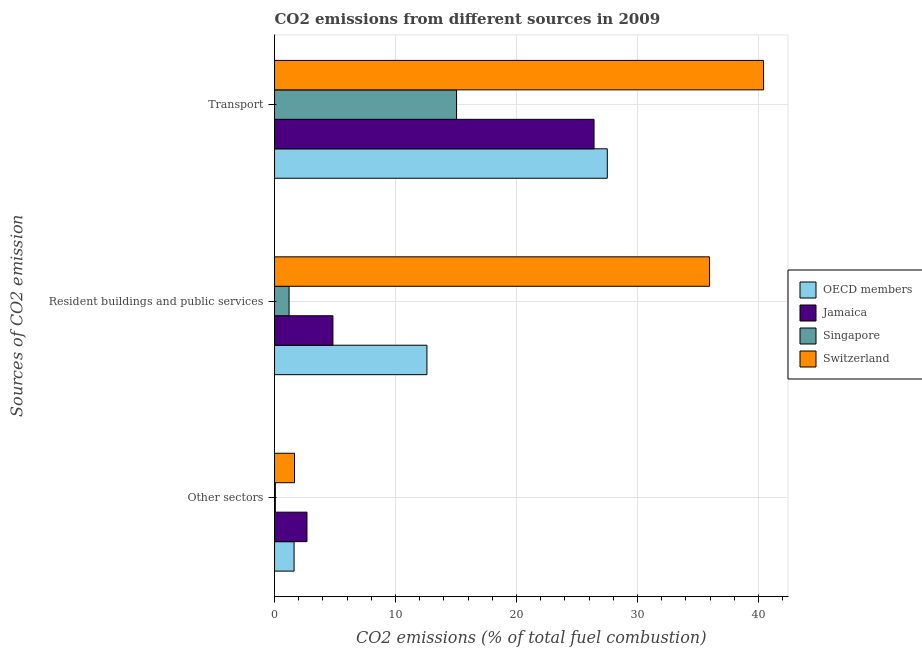How many groups of bars are there?
Give a very brief answer. 3. Are the number of bars on each tick of the Y-axis equal?
Make the answer very short. Yes. How many bars are there on the 1st tick from the top?
Offer a terse response. 4. What is the label of the 2nd group of bars from the top?
Your response must be concise. Resident buildings and public services. What is the percentage of co2 emissions from transport in Jamaica?
Provide a short and direct response. 26.41. Across all countries, what is the maximum percentage of co2 emissions from transport?
Provide a succinct answer. 40.42. Across all countries, what is the minimum percentage of co2 emissions from other sectors?
Your answer should be compact. 0.07. In which country was the percentage of co2 emissions from transport maximum?
Provide a succinct answer. Switzerland. In which country was the percentage of co2 emissions from transport minimum?
Your response must be concise. Singapore. What is the total percentage of co2 emissions from other sectors in the graph?
Offer a very short reply. 6.02. What is the difference between the percentage of co2 emissions from resident buildings and public services in OECD members and that in Jamaica?
Provide a short and direct response. 7.77. What is the difference between the percentage of co2 emissions from other sectors in Singapore and the percentage of co2 emissions from resident buildings and public services in Jamaica?
Keep it short and to the point. -4.76. What is the average percentage of co2 emissions from transport per country?
Give a very brief answer. 27.34. What is the difference between the percentage of co2 emissions from resident buildings and public services and percentage of co2 emissions from other sectors in OECD members?
Give a very brief answer. 10.98. What is the ratio of the percentage of co2 emissions from other sectors in Jamaica to that in Switzerland?
Your response must be concise. 1.62. Is the percentage of co2 emissions from other sectors in Singapore less than that in Switzerland?
Offer a terse response. Yes. What is the difference between the highest and the second highest percentage of co2 emissions from other sectors?
Make the answer very short. 1.03. What is the difference between the highest and the lowest percentage of co2 emissions from other sectors?
Provide a succinct answer. 2.61. In how many countries, is the percentage of co2 emissions from other sectors greater than the average percentage of co2 emissions from other sectors taken over all countries?
Keep it short and to the point. 3. What does the 3rd bar from the top in Other sectors represents?
Make the answer very short. Jamaica. What does the 2nd bar from the bottom in Transport represents?
Provide a short and direct response. Jamaica. Is it the case that in every country, the sum of the percentage of co2 emissions from other sectors and percentage of co2 emissions from resident buildings and public services is greater than the percentage of co2 emissions from transport?
Your response must be concise. No. What is the difference between two consecutive major ticks on the X-axis?
Your answer should be very brief. 10. Are the values on the major ticks of X-axis written in scientific E-notation?
Your answer should be compact. No. Does the graph contain grids?
Give a very brief answer. Yes. How many legend labels are there?
Provide a short and direct response. 4. What is the title of the graph?
Provide a succinct answer. CO2 emissions from different sources in 2009. Does "Mauritania" appear as one of the legend labels in the graph?
Give a very brief answer. No. What is the label or title of the X-axis?
Provide a short and direct response. CO2 emissions (% of total fuel combustion). What is the label or title of the Y-axis?
Provide a short and direct response. Sources of CO2 emission. What is the CO2 emissions (% of total fuel combustion) of OECD members in Other sectors?
Provide a short and direct response. 1.62. What is the CO2 emissions (% of total fuel combustion) of Jamaica in Other sectors?
Offer a very short reply. 2.68. What is the CO2 emissions (% of total fuel combustion) in Singapore in Other sectors?
Provide a succinct answer. 0.07. What is the CO2 emissions (% of total fuel combustion) in Switzerland in Other sectors?
Keep it short and to the point. 1.65. What is the CO2 emissions (% of total fuel combustion) of OECD members in Resident buildings and public services?
Keep it short and to the point. 12.6. What is the CO2 emissions (% of total fuel combustion) of Jamaica in Resident buildings and public services?
Offer a very short reply. 4.83. What is the CO2 emissions (% of total fuel combustion) of Singapore in Resident buildings and public services?
Make the answer very short. 1.2. What is the CO2 emissions (% of total fuel combustion) of Switzerland in Resident buildings and public services?
Keep it short and to the point. 35.95. What is the CO2 emissions (% of total fuel combustion) of OECD members in Transport?
Your answer should be compact. 27.5. What is the CO2 emissions (% of total fuel combustion) of Jamaica in Transport?
Offer a very short reply. 26.41. What is the CO2 emissions (% of total fuel combustion) of Singapore in Transport?
Ensure brevity in your answer.  15.04. What is the CO2 emissions (% of total fuel combustion) of Switzerland in Transport?
Provide a short and direct response. 40.42. Across all Sources of CO2 emission, what is the maximum CO2 emissions (% of total fuel combustion) of OECD members?
Provide a succinct answer. 27.5. Across all Sources of CO2 emission, what is the maximum CO2 emissions (% of total fuel combustion) of Jamaica?
Provide a succinct answer. 26.41. Across all Sources of CO2 emission, what is the maximum CO2 emissions (% of total fuel combustion) of Singapore?
Ensure brevity in your answer.  15.04. Across all Sources of CO2 emission, what is the maximum CO2 emissions (% of total fuel combustion) in Switzerland?
Your answer should be compact. 40.42. Across all Sources of CO2 emission, what is the minimum CO2 emissions (% of total fuel combustion) of OECD members?
Offer a very short reply. 1.62. Across all Sources of CO2 emission, what is the minimum CO2 emissions (% of total fuel combustion) in Jamaica?
Ensure brevity in your answer.  2.68. Across all Sources of CO2 emission, what is the minimum CO2 emissions (% of total fuel combustion) of Singapore?
Give a very brief answer. 0.07. Across all Sources of CO2 emission, what is the minimum CO2 emissions (% of total fuel combustion) in Switzerland?
Give a very brief answer. 1.65. What is the total CO2 emissions (% of total fuel combustion) of OECD members in the graph?
Offer a very short reply. 41.71. What is the total CO2 emissions (% of total fuel combustion) in Jamaica in the graph?
Offer a very short reply. 33.91. What is the total CO2 emissions (% of total fuel combustion) of Singapore in the graph?
Give a very brief answer. 16.32. What is the total CO2 emissions (% of total fuel combustion) of Switzerland in the graph?
Keep it short and to the point. 78.02. What is the difference between the CO2 emissions (% of total fuel combustion) in OECD members in Other sectors and that in Resident buildings and public services?
Provide a succinct answer. -10.98. What is the difference between the CO2 emissions (% of total fuel combustion) of Jamaica in Other sectors and that in Resident buildings and public services?
Your answer should be very brief. -2.14. What is the difference between the CO2 emissions (% of total fuel combustion) in Singapore in Other sectors and that in Resident buildings and public services?
Ensure brevity in your answer.  -1.13. What is the difference between the CO2 emissions (% of total fuel combustion) of Switzerland in Other sectors and that in Resident buildings and public services?
Keep it short and to the point. -34.3. What is the difference between the CO2 emissions (% of total fuel combustion) in OECD members in Other sectors and that in Transport?
Provide a short and direct response. -25.89. What is the difference between the CO2 emissions (% of total fuel combustion) of Jamaica in Other sectors and that in Transport?
Provide a short and direct response. -23.73. What is the difference between the CO2 emissions (% of total fuel combustion) of Singapore in Other sectors and that in Transport?
Make the answer very short. -14.98. What is the difference between the CO2 emissions (% of total fuel combustion) of Switzerland in Other sectors and that in Transport?
Give a very brief answer. -38.76. What is the difference between the CO2 emissions (% of total fuel combustion) of OECD members in Resident buildings and public services and that in Transport?
Keep it short and to the point. -14.91. What is the difference between the CO2 emissions (% of total fuel combustion) in Jamaica in Resident buildings and public services and that in Transport?
Offer a very short reply. -21.58. What is the difference between the CO2 emissions (% of total fuel combustion) of Singapore in Resident buildings and public services and that in Transport?
Offer a very short reply. -13.84. What is the difference between the CO2 emissions (% of total fuel combustion) in Switzerland in Resident buildings and public services and that in Transport?
Keep it short and to the point. -4.46. What is the difference between the CO2 emissions (% of total fuel combustion) of OECD members in Other sectors and the CO2 emissions (% of total fuel combustion) of Jamaica in Resident buildings and public services?
Your response must be concise. -3.21. What is the difference between the CO2 emissions (% of total fuel combustion) in OECD members in Other sectors and the CO2 emissions (% of total fuel combustion) in Singapore in Resident buildings and public services?
Your answer should be very brief. 0.41. What is the difference between the CO2 emissions (% of total fuel combustion) of OECD members in Other sectors and the CO2 emissions (% of total fuel combustion) of Switzerland in Resident buildings and public services?
Your answer should be compact. -34.34. What is the difference between the CO2 emissions (% of total fuel combustion) of Jamaica in Other sectors and the CO2 emissions (% of total fuel combustion) of Singapore in Resident buildings and public services?
Offer a very short reply. 1.48. What is the difference between the CO2 emissions (% of total fuel combustion) in Jamaica in Other sectors and the CO2 emissions (% of total fuel combustion) in Switzerland in Resident buildings and public services?
Your answer should be very brief. -33.27. What is the difference between the CO2 emissions (% of total fuel combustion) of Singapore in Other sectors and the CO2 emissions (% of total fuel combustion) of Switzerland in Resident buildings and public services?
Keep it short and to the point. -35.89. What is the difference between the CO2 emissions (% of total fuel combustion) of OECD members in Other sectors and the CO2 emissions (% of total fuel combustion) of Jamaica in Transport?
Offer a very short reply. -24.79. What is the difference between the CO2 emissions (% of total fuel combustion) of OECD members in Other sectors and the CO2 emissions (% of total fuel combustion) of Singapore in Transport?
Your response must be concise. -13.43. What is the difference between the CO2 emissions (% of total fuel combustion) of OECD members in Other sectors and the CO2 emissions (% of total fuel combustion) of Switzerland in Transport?
Keep it short and to the point. -38.8. What is the difference between the CO2 emissions (% of total fuel combustion) of Jamaica in Other sectors and the CO2 emissions (% of total fuel combustion) of Singapore in Transport?
Your answer should be compact. -12.36. What is the difference between the CO2 emissions (% of total fuel combustion) of Jamaica in Other sectors and the CO2 emissions (% of total fuel combustion) of Switzerland in Transport?
Your answer should be very brief. -37.73. What is the difference between the CO2 emissions (% of total fuel combustion) of Singapore in Other sectors and the CO2 emissions (% of total fuel combustion) of Switzerland in Transport?
Provide a succinct answer. -40.35. What is the difference between the CO2 emissions (% of total fuel combustion) of OECD members in Resident buildings and public services and the CO2 emissions (% of total fuel combustion) of Jamaica in Transport?
Your answer should be very brief. -13.81. What is the difference between the CO2 emissions (% of total fuel combustion) in OECD members in Resident buildings and public services and the CO2 emissions (% of total fuel combustion) in Singapore in Transport?
Your response must be concise. -2.45. What is the difference between the CO2 emissions (% of total fuel combustion) in OECD members in Resident buildings and public services and the CO2 emissions (% of total fuel combustion) in Switzerland in Transport?
Your answer should be compact. -27.82. What is the difference between the CO2 emissions (% of total fuel combustion) in Jamaica in Resident buildings and public services and the CO2 emissions (% of total fuel combustion) in Singapore in Transport?
Your answer should be compact. -10.22. What is the difference between the CO2 emissions (% of total fuel combustion) of Jamaica in Resident buildings and public services and the CO2 emissions (% of total fuel combustion) of Switzerland in Transport?
Offer a very short reply. -35.59. What is the difference between the CO2 emissions (% of total fuel combustion) in Singapore in Resident buildings and public services and the CO2 emissions (% of total fuel combustion) in Switzerland in Transport?
Give a very brief answer. -39.21. What is the average CO2 emissions (% of total fuel combustion) of OECD members per Sources of CO2 emission?
Give a very brief answer. 13.9. What is the average CO2 emissions (% of total fuel combustion) of Jamaica per Sources of CO2 emission?
Your answer should be very brief. 11.3. What is the average CO2 emissions (% of total fuel combustion) of Singapore per Sources of CO2 emission?
Your answer should be compact. 5.44. What is the average CO2 emissions (% of total fuel combustion) in Switzerland per Sources of CO2 emission?
Offer a very short reply. 26.01. What is the difference between the CO2 emissions (% of total fuel combustion) of OECD members and CO2 emissions (% of total fuel combustion) of Jamaica in Other sectors?
Your answer should be very brief. -1.07. What is the difference between the CO2 emissions (% of total fuel combustion) of OECD members and CO2 emissions (% of total fuel combustion) of Singapore in Other sectors?
Offer a terse response. 1.55. What is the difference between the CO2 emissions (% of total fuel combustion) in OECD members and CO2 emissions (% of total fuel combustion) in Switzerland in Other sectors?
Give a very brief answer. -0.04. What is the difference between the CO2 emissions (% of total fuel combustion) of Jamaica and CO2 emissions (% of total fuel combustion) of Singapore in Other sectors?
Offer a very short reply. 2.61. What is the difference between the CO2 emissions (% of total fuel combustion) in Jamaica and CO2 emissions (% of total fuel combustion) in Switzerland in Other sectors?
Your answer should be very brief. 1.03. What is the difference between the CO2 emissions (% of total fuel combustion) of Singapore and CO2 emissions (% of total fuel combustion) of Switzerland in Other sectors?
Provide a short and direct response. -1.58. What is the difference between the CO2 emissions (% of total fuel combustion) in OECD members and CO2 emissions (% of total fuel combustion) in Jamaica in Resident buildings and public services?
Your answer should be very brief. 7.77. What is the difference between the CO2 emissions (% of total fuel combustion) of OECD members and CO2 emissions (% of total fuel combustion) of Singapore in Resident buildings and public services?
Provide a short and direct response. 11.39. What is the difference between the CO2 emissions (% of total fuel combustion) in OECD members and CO2 emissions (% of total fuel combustion) in Switzerland in Resident buildings and public services?
Offer a terse response. -23.36. What is the difference between the CO2 emissions (% of total fuel combustion) of Jamaica and CO2 emissions (% of total fuel combustion) of Singapore in Resident buildings and public services?
Give a very brief answer. 3.62. What is the difference between the CO2 emissions (% of total fuel combustion) in Jamaica and CO2 emissions (% of total fuel combustion) in Switzerland in Resident buildings and public services?
Your answer should be compact. -31.13. What is the difference between the CO2 emissions (% of total fuel combustion) in Singapore and CO2 emissions (% of total fuel combustion) in Switzerland in Resident buildings and public services?
Your answer should be compact. -34.75. What is the difference between the CO2 emissions (% of total fuel combustion) of OECD members and CO2 emissions (% of total fuel combustion) of Jamaica in Transport?
Provide a succinct answer. 1.09. What is the difference between the CO2 emissions (% of total fuel combustion) of OECD members and CO2 emissions (% of total fuel combustion) of Singapore in Transport?
Offer a very short reply. 12.46. What is the difference between the CO2 emissions (% of total fuel combustion) of OECD members and CO2 emissions (% of total fuel combustion) of Switzerland in Transport?
Your response must be concise. -12.91. What is the difference between the CO2 emissions (% of total fuel combustion) in Jamaica and CO2 emissions (% of total fuel combustion) in Singapore in Transport?
Keep it short and to the point. 11.36. What is the difference between the CO2 emissions (% of total fuel combustion) in Jamaica and CO2 emissions (% of total fuel combustion) in Switzerland in Transport?
Offer a very short reply. -14.01. What is the difference between the CO2 emissions (% of total fuel combustion) of Singapore and CO2 emissions (% of total fuel combustion) of Switzerland in Transport?
Keep it short and to the point. -25.37. What is the ratio of the CO2 emissions (% of total fuel combustion) of OECD members in Other sectors to that in Resident buildings and public services?
Ensure brevity in your answer.  0.13. What is the ratio of the CO2 emissions (% of total fuel combustion) of Jamaica in Other sectors to that in Resident buildings and public services?
Your answer should be very brief. 0.56. What is the ratio of the CO2 emissions (% of total fuel combustion) in Singapore in Other sectors to that in Resident buildings and public services?
Provide a succinct answer. 0.06. What is the ratio of the CO2 emissions (% of total fuel combustion) in Switzerland in Other sectors to that in Resident buildings and public services?
Ensure brevity in your answer.  0.05. What is the ratio of the CO2 emissions (% of total fuel combustion) in OECD members in Other sectors to that in Transport?
Provide a succinct answer. 0.06. What is the ratio of the CO2 emissions (% of total fuel combustion) in Jamaica in Other sectors to that in Transport?
Offer a very short reply. 0.1. What is the ratio of the CO2 emissions (% of total fuel combustion) in Singapore in Other sectors to that in Transport?
Give a very brief answer. 0. What is the ratio of the CO2 emissions (% of total fuel combustion) of Switzerland in Other sectors to that in Transport?
Make the answer very short. 0.04. What is the ratio of the CO2 emissions (% of total fuel combustion) of OECD members in Resident buildings and public services to that in Transport?
Give a very brief answer. 0.46. What is the ratio of the CO2 emissions (% of total fuel combustion) in Jamaica in Resident buildings and public services to that in Transport?
Your response must be concise. 0.18. What is the ratio of the CO2 emissions (% of total fuel combustion) in Singapore in Resident buildings and public services to that in Transport?
Provide a short and direct response. 0.08. What is the ratio of the CO2 emissions (% of total fuel combustion) of Switzerland in Resident buildings and public services to that in Transport?
Keep it short and to the point. 0.89. What is the difference between the highest and the second highest CO2 emissions (% of total fuel combustion) of OECD members?
Keep it short and to the point. 14.91. What is the difference between the highest and the second highest CO2 emissions (% of total fuel combustion) of Jamaica?
Give a very brief answer. 21.58. What is the difference between the highest and the second highest CO2 emissions (% of total fuel combustion) of Singapore?
Make the answer very short. 13.84. What is the difference between the highest and the second highest CO2 emissions (% of total fuel combustion) of Switzerland?
Keep it short and to the point. 4.46. What is the difference between the highest and the lowest CO2 emissions (% of total fuel combustion) in OECD members?
Your answer should be very brief. 25.89. What is the difference between the highest and the lowest CO2 emissions (% of total fuel combustion) in Jamaica?
Provide a short and direct response. 23.73. What is the difference between the highest and the lowest CO2 emissions (% of total fuel combustion) of Singapore?
Provide a succinct answer. 14.98. What is the difference between the highest and the lowest CO2 emissions (% of total fuel combustion) of Switzerland?
Your response must be concise. 38.76. 